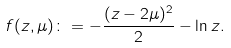<formula> <loc_0><loc_0><loc_500><loc_500>f ( z , \mu ) \colon = - \frac { ( z - 2 \mu ) ^ { 2 } } 2 - \ln z .</formula> 